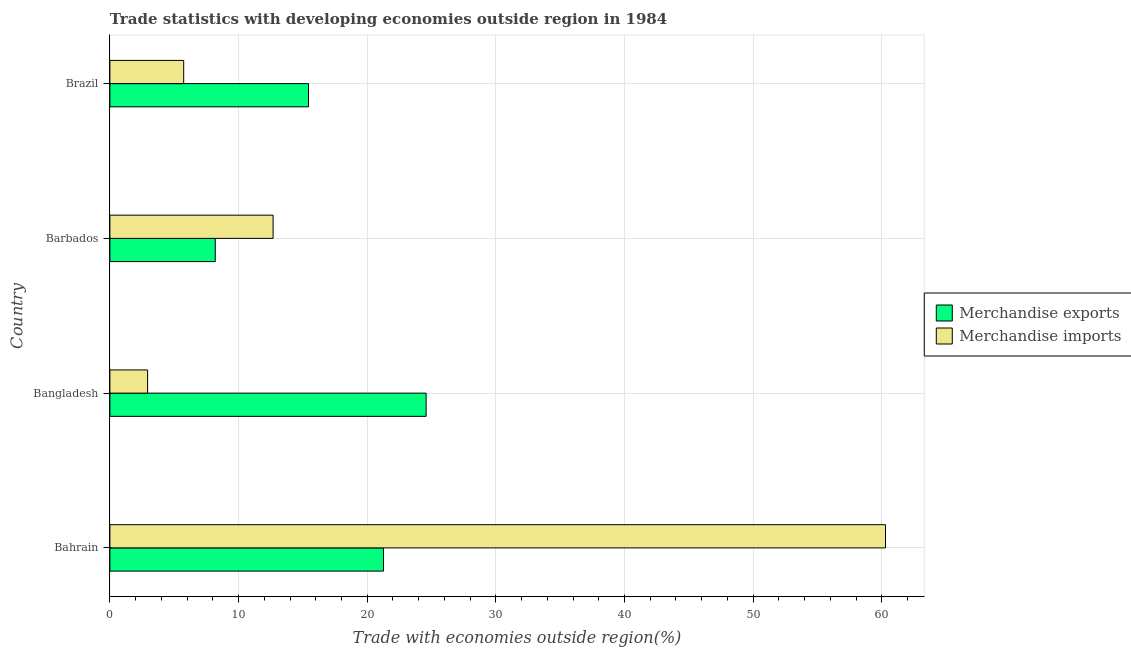How many different coloured bars are there?
Ensure brevity in your answer.  2. How many bars are there on the 4th tick from the top?
Your answer should be compact. 2. What is the merchandise imports in Brazil?
Offer a very short reply. 5.74. Across all countries, what is the maximum merchandise exports?
Offer a very short reply. 24.58. Across all countries, what is the minimum merchandise exports?
Offer a very short reply. 8.19. In which country was the merchandise exports maximum?
Your answer should be compact. Bangladesh. What is the total merchandise exports in the graph?
Ensure brevity in your answer.  69.48. What is the difference between the merchandise imports in Bahrain and that in Brazil?
Offer a very short reply. 54.55. What is the difference between the merchandise imports in Bangladesh and the merchandise exports in Barbados?
Your response must be concise. -5.26. What is the average merchandise imports per country?
Keep it short and to the point. 20.41. What is the difference between the merchandise exports and merchandise imports in Bahrain?
Your answer should be compact. -39.02. In how many countries, is the merchandise imports greater than 12 %?
Your response must be concise. 2. What is the ratio of the merchandise imports in Bahrain to that in Brazil?
Your answer should be very brief. 10.51. Is the merchandise imports in Barbados less than that in Brazil?
Make the answer very short. No. Is the difference between the merchandise imports in Bahrain and Barbados greater than the difference between the merchandise exports in Bahrain and Barbados?
Offer a terse response. Yes. What is the difference between the highest and the second highest merchandise exports?
Your answer should be very brief. 3.32. What is the difference between the highest and the lowest merchandise exports?
Provide a succinct answer. 16.39. In how many countries, is the merchandise imports greater than the average merchandise imports taken over all countries?
Provide a succinct answer. 1. What does the 1st bar from the top in Bahrain represents?
Give a very brief answer. Merchandise imports. What does the 1st bar from the bottom in Bahrain represents?
Give a very brief answer. Merchandise exports. How many bars are there?
Offer a very short reply. 8. Are all the bars in the graph horizontal?
Keep it short and to the point. Yes. How many countries are there in the graph?
Keep it short and to the point. 4. What is the difference between two consecutive major ticks on the X-axis?
Provide a short and direct response. 10. Are the values on the major ticks of X-axis written in scientific E-notation?
Offer a terse response. No. Does the graph contain any zero values?
Your answer should be compact. No. Where does the legend appear in the graph?
Provide a short and direct response. Center right. What is the title of the graph?
Provide a succinct answer. Trade statistics with developing economies outside region in 1984. What is the label or title of the X-axis?
Your answer should be compact. Trade with economies outside region(%). What is the Trade with economies outside region(%) of Merchandise exports in Bahrain?
Offer a very short reply. 21.27. What is the Trade with economies outside region(%) of Merchandise imports in Bahrain?
Give a very brief answer. 60.29. What is the Trade with economies outside region(%) in Merchandise exports in Bangladesh?
Your answer should be very brief. 24.58. What is the Trade with economies outside region(%) of Merchandise imports in Bangladesh?
Offer a very short reply. 2.93. What is the Trade with economies outside region(%) in Merchandise exports in Barbados?
Your answer should be compact. 8.19. What is the Trade with economies outside region(%) in Merchandise imports in Barbados?
Your answer should be compact. 12.69. What is the Trade with economies outside region(%) in Merchandise exports in Brazil?
Offer a very short reply. 15.44. What is the Trade with economies outside region(%) in Merchandise imports in Brazil?
Provide a succinct answer. 5.74. Across all countries, what is the maximum Trade with economies outside region(%) of Merchandise exports?
Ensure brevity in your answer.  24.58. Across all countries, what is the maximum Trade with economies outside region(%) in Merchandise imports?
Offer a terse response. 60.29. Across all countries, what is the minimum Trade with economies outside region(%) in Merchandise exports?
Your response must be concise. 8.19. Across all countries, what is the minimum Trade with economies outside region(%) of Merchandise imports?
Your answer should be compact. 2.93. What is the total Trade with economies outside region(%) in Merchandise exports in the graph?
Provide a short and direct response. 69.48. What is the total Trade with economies outside region(%) in Merchandise imports in the graph?
Give a very brief answer. 81.65. What is the difference between the Trade with economies outside region(%) in Merchandise exports in Bahrain and that in Bangladesh?
Your answer should be compact. -3.32. What is the difference between the Trade with economies outside region(%) in Merchandise imports in Bahrain and that in Bangladesh?
Ensure brevity in your answer.  57.36. What is the difference between the Trade with economies outside region(%) in Merchandise exports in Bahrain and that in Barbados?
Your answer should be compact. 13.08. What is the difference between the Trade with economies outside region(%) of Merchandise imports in Bahrain and that in Barbados?
Make the answer very short. 47.6. What is the difference between the Trade with economies outside region(%) of Merchandise exports in Bahrain and that in Brazil?
Your answer should be compact. 5.83. What is the difference between the Trade with economies outside region(%) in Merchandise imports in Bahrain and that in Brazil?
Your answer should be compact. 54.55. What is the difference between the Trade with economies outside region(%) in Merchandise exports in Bangladesh and that in Barbados?
Make the answer very short. 16.39. What is the difference between the Trade with economies outside region(%) of Merchandise imports in Bangladesh and that in Barbados?
Provide a short and direct response. -9.76. What is the difference between the Trade with economies outside region(%) of Merchandise exports in Bangladesh and that in Brazil?
Make the answer very short. 9.14. What is the difference between the Trade with economies outside region(%) of Merchandise imports in Bangladesh and that in Brazil?
Your answer should be compact. -2.8. What is the difference between the Trade with economies outside region(%) in Merchandise exports in Barbados and that in Brazil?
Offer a terse response. -7.25. What is the difference between the Trade with economies outside region(%) of Merchandise imports in Barbados and that in Brazil?
Give a very brief answer. 6.95. What is the difference between the Trade with economies outside region(%) of Merchandise exports in Bahrain and the Trade with economies outside region(%) of Merchandise imports in Bangladesh?
Ensure brevity in your answer.  18.33. What is the difference between the Trade with economies outside region(%) of Merchandise exports in Bahrain and the Trade with economies outside region(%) of Merchandise imports in Barbados?
Keep it short and to the point. 8.58. What is the difference between the Trade with economies outside region(%) in Merchandise exports in Bahrain and the Trade with economies outside region(%) in Merchandise imports in Brazil?
Your answer should be very brief. 15.53. What is the difference between the Trade with economies outside region(%) in Merchandise exports in Bangladesh and the Trade with economies outside region(%) in Merchandise imports in Barbados?
Ensure brevity in your answer.  11.9. What is the difference between the Trade with economies outside region(%) of Merchandise exports in Bangladesh and the Trade with economies outside region(%) of Merchandise imports in Brazil?
Provide a short and direct response. 18.85. What is the difference between the Trade with economies outside region(%) of Merchandise exports in Barbados and the Trade with economies outside region(%) of Merchandise imports in Brazil?
Your answer should be very brief. 2.45. What is the average Trade with economies outside region(%) in Merchandise exports per country?
Offer a very short reply. 17.37. What is the average Trade with economies outside region(%) in Merchandise imports per country?
Give a very brief answer. 20.41. What is the difference between the Trade with economies outside region(%) of Merchandise exports and Trade with economies outside region(%) of Merchandise imports in Bahrain?
Provide a short and direct response. -39.02. What is the difference between the Trade with economies outside region(%) of Merchandise exports and Trade with economies outside region(%) of Merchandise imports in Bangladesh?
Your answer should be compact. 21.65. What is the difference between the Trade with economies outside region(%) of Merchandise exports and Trade with economies outside region(%) of Merchandise imports in Barbados?
Provide a short and direct response. -4.5. What is the difference between the Trade with economies outside region(%) in Merchandise exports and Trade with economies outside region(%) in Merchandise imports in Brazil?
Offer a terse response. 9.7. What is the ratio of the Trade with economies outside region(%) of Merchandise exports in Bahrain to that in Bangladesh?
Provide a short and direct response. 0.87. What is the ratio of the Trade with economies outside region(%) of Merchandise imports in Bahrain to that in Bangladesh?
Give a very brief answer. 20.57. What is the ratio of the Trade with economies outside region(%) of Merchandise exports in Bahrain to that in Barbados?
Make the answer very short. 2.6. What is the ratio of the Trade with economies outside region(%) in Merchandise imports in Bahrain to that in Barbados?
Your response must be concise. 4.75. What is the ratio of the Trade with economies outside region(%) in Merchandise exports in Bahrain to that in Brazil?
Give a very brief answer. 1.38. What is the ratio of the Trade with economies outside region(%) in Merchandise imports in Bahrain to that in Brazil?
Keep it short and to the point. 10.51. What is the ratio of the Trade with economies outside region(%) of Merchandise exports in Bangladesh to that in Barbados?
Keep it short and to the point. 3. What is the ratio of the Trade with economies outside region(%) of Merchandise imports in Bangladesh to that in Barbados?
Offer a very short reply. 0.23. What is the ratio of the Trade with economies outside region(%) in Merchandise exports in Bangladesh to that in Brazil?
Ensure brevity in your answer.  1.59. What is the ratio of the Trade with economies outside region(%) in Merchandise imports in Bangladesh to that in Brazil?
Offer a terse response. 0.51. What is the ratio of the Trade with economies outside region(%) of Merchandise exports in Barbados to that in Brazil?
Provide a succinct answer. 0.53. What is the ratio of the Trade with economies outside region(%) of Merchandise imports in Barbados to that in Brazil?
Provide a succinct answer. 2.21. What is the difference between the highest and the second highest Trade with economies outside region(%) in Merchandise exports?
Offer a very short reply. 3.32. What is the difference between the highest and the second highest Trade with economies outside region(%) of Merchandise imports?
Ensure brevity in your answer.  47.6. What is the difference between the highest and the lowest Trade with economies outside region(%) of Merchandise exports?
Provide a succinct answer. 16.39. What is the difference between the highest and the lowest Trade with economies outside region(%) in Merchandise imports?
Make the answer very short. 57.36. 